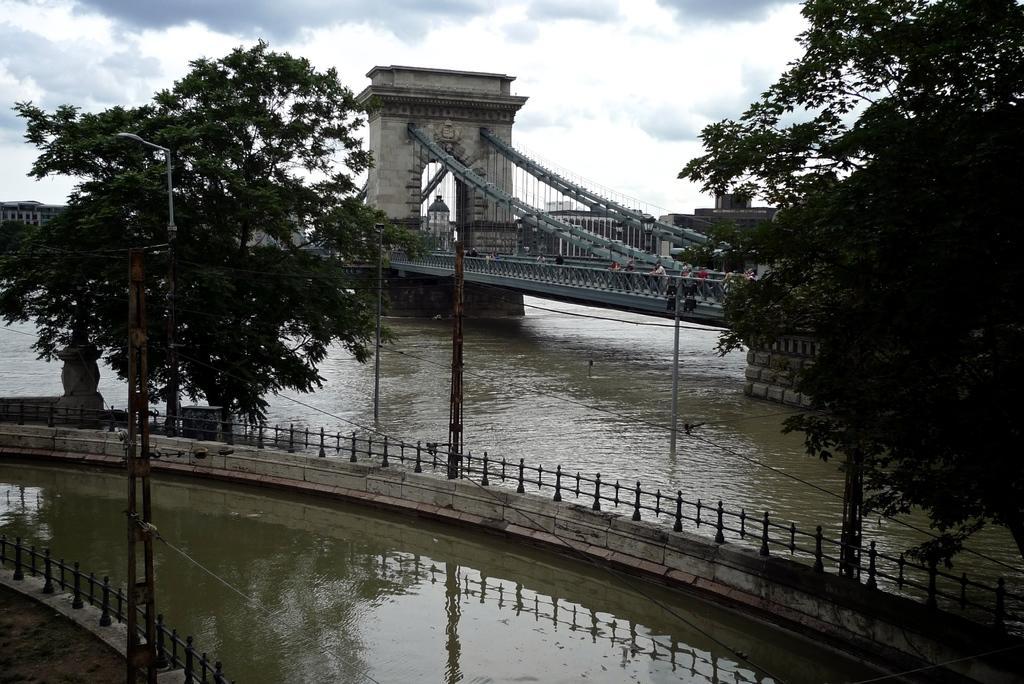Could you give a brief overview of what you see in this image? In the center of the image there is a bridge and persons. At the bottom of the image we can see water and wall fencing. On the right and left side of the images we can see buildings and trees. In the background there are building, sky and clouds. 